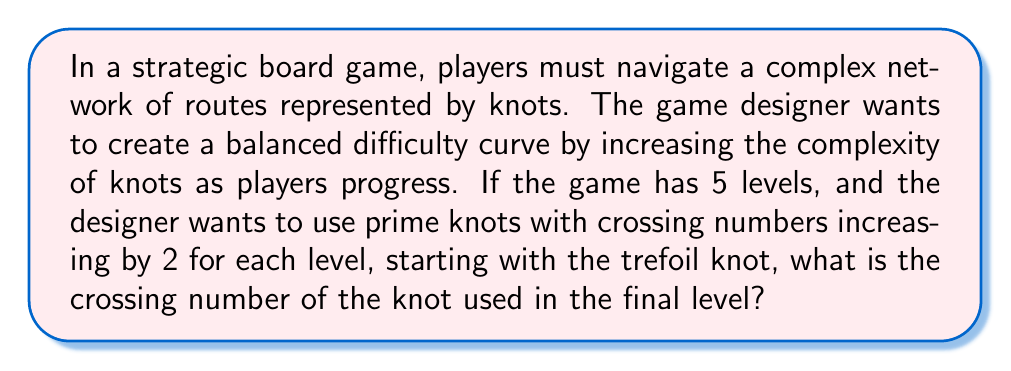Can you solve this math problem? Let's approach this step-by-step:

1) First, recall that the trefoil knot is the simplest non-trivial knot, with a crossing number of 3.

2) The designer wants to increase the crossing number by 2 for each level. We can represent this as an arithmetic sequence:

   $a_n = a_1 + (n-1)d$

   Where $a_n$ is the nth term, $a_1$ is the first term, $n$ is the position in the sequence, and $d$ is the common difference.

3) In this case:
   $a_1 = 3$ (crossing number of trefoil knot)
   $d = 2$ (increase in crossing number per level)
   $n = 5$ (we want to find the 5th term, for the final level)

4) Substituting these values into our formula:

   $a_5 = 3 + (5-1)2$
   $a_5 = 3 + 8$
   $a_5 = 11$

5) Therefore, the crossing number for the knot in the final level is 11.

6) It's worth noting that this sequence (3, 5, 7, 9, 11) indeed represents the crossing numbers of the first five prime knots: the trefoil (3_1), the figure-eight knot (4_1), and the first three 5-crossing knots (5_1, 5_2, 5_3).

This progression provides a natural increase in complexity, which aligns well with the game's difficulty curve.
Answer: 11 